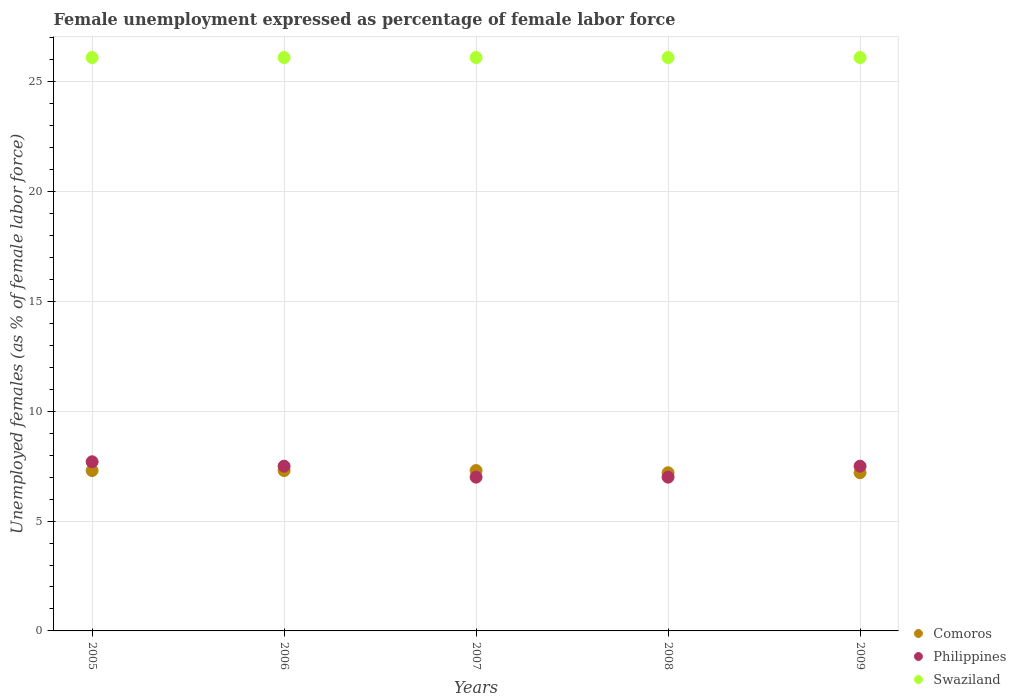How many different coloured dotlines are there?
Offer a terse response. 3. What is the unemployment in females in in Philippines in 2009?
Offer a very short reply. 7.5. Across all years, what is the maximum unemployment in females in in Philippines?
Offer a very short reply. 7.7. Across all years, what is the minimum unemployment in females in in Comoros?
Provide a succinct answer. 7.2. What is the total unemployment in females in in Philippines in the graph?
Ensure brevity in your answer.  36.7. What is the difference between the unemployment in females in in Swaziland in 2005 and the unemployment in females in in Philippines in 2008?
Provide a short and direct response. 19.1. What is the average unemployment in females in in Philippines per year?
Offer a terse response. 7.34. In the year 2007, what is the difference between the unemployment in females in in Comoros and unemployment in females in in Philippines?
Provide a succinct answer. 0.3. What is the ratio of the unemployment in females in in Philippines in 2005 to that in 2008?
Keep it short and to the point. 1.1. Is the unemployment in females in in Comoros in 2005 less than that in 2007?
Provide a short and direct response. No. Is the difference between the unemployment in females in in Comoros in 2008 and 2009 greater than the difference between the unemployment in females in in Philippines in 2008 and 2009?
Make the answer very short. Yes. What is the difference between the highest and the second highest unemployment in females in in Comoros?
Keep it short and to the point. 0. What is the difference between the highest and the lowest unemployment in females in in Swaziland?
Keep it short and to the point. 0. What is the difference between two consecutive major ticks on the Y-axis?
Your answer should be compact. 5. Does the graph contain any zero values?
Make the answer very short. No. Does the graph contain grids?
Ensure brevity in your answer.  Yes. Where does the legend appear in the graph?
Give a very brief answer. Bottom right. What is the title of the graph?
Keep it short and to the point. Female unemployment expressed as percentage of female labor force. What is the label or title of the X-axis?
Give a very brief answer. Years. What is the label or title of the Y-axis?
Your answer should be compact. Unemployed females (as % of female labor force). What is the Unemployed females (as % of female labor force) in Comoros in 2005?
Offer a very short reply. 7.3. What is the Unemployed females (as % of female labor force) of Philippines in 2005?
Ensure brevity in your answer.  7.7. What is the Unemployed females (as % of female labor force) in Swaziland in 2005?
Provide a short and direct response. 26.1. What is the Unemployed females (as % of female labor force) of Comoros in 2006?
Ensure brevity in your answer.  7.3. What is the Unemployed females (as % of female labor force) of Swaziland in 2006?
Provide a succinct answer. 26.1. What is the Unemployed females (as % of female labor force) in Comoros in 2007?
Your answer should be very brief. 7.3. What is the Unemployed females (as % of female labor force) in Swaziland in 2007?
Provide a short and direct response. 26.1. What is the Unemployed females (as % of female labor force) in Comoros in 2008?
Make the answer very short. 7.2. What is the Unemployed females (as % of female labor force) of Swaziland in 2008?
Make the answer very short. 26.1. What is the Unemployed females (as % of female labor force) in Comoros in 2009?
Keep it short and to the point. 7.2. What is the Unemployed females (as % of female labor force) of Philippines in 2009?
Your response must be concise. 7.5. What is the Unemployed females (as % of female labor force) in Swaziland in 2009?
Give a very brief answer. 26.1. Across all years, what is the maximum Unemployed females (as % of female labor force) in Comoros?
Provide a short and direct response. 7.3. Across all years, what is the maximum Unemployed females (as % of female labor force) in Philippines?
Offer a terse response. 7.7. Across all years, what is the maximum Unemployed females (as % of female labor force) of Swaziland?
Your response must be concise. 26.1. Across all years, what is the minimum Unemployed females (as % of female labor force) of Comoros?
Make the answer very short. 7.2. Across all years, what is the minimum Unemployed females (as % of female labor force) of Swaziland?
Your answer should be very brief. 26.1. What is the total Unemployed females (as % of female labor force) in Comoros in the graph?
Give a very brief answer. 36.3. What is the total Unemployed females (as % of female labor force) of Philippines in the graph?
Offer a very short reply. 36.7. What is the total Unemployed females (as % of female labor force) in Swaziland in the graph?
Your answer should be compact. 130.5. What is the difference between the Unemployed females (as % of female labor force) of Comoros in 2005 and that in 2006?
Give a very brief answer. 0. What is the difference between the Unemployed females (as % of female labor force) of Philippines in 2005 and that in 2006?
Provide a short and direct response. 0.2. What is the difference between the Unemployed females (as % of female labor force) in Swaziland in 2005 and that in 2006?
Keep it short and to the point. 0. What is the difference between the Unemployed females (as % of female labor force) of Philippines in 2005 and that in 2008?
Your response must be concise. 0.7. What is the difference between the Unemployed females (as % of female labor force) of Comoros in 2005 and that in 2009?
Keep it short and to the point. 0.1. What is the difference between the Unemployed females (as % of female labor force) in Philippines in 2005 and that in 2009?
Your answer should be very brief. 0.2. What is the difference between the Unemployed females (as % of female labor force) in Swaziland in 2005 and that in 2009?
Provide a succinct answer. 0. What is the difference between the Unemployed females (as % of female labor force) in Philippines in 2006 and that in 2008?
Your answer should be very brief. 0.5. What is the difference between the Unemployed females (as % of female labor force) of Swaziland in 2006 and that in 2009?
Offer a very short reply. 0. What is the difference between the Unemployed females (as % of female labor force) in Swaziland in 2007 and that in 2008?
Provide a succinct answer. 0. What is the difference between the Unemployed females (as % of female labor force) of Comoros in 2007 and that in 2009?
Your answer should be compact. 0.1. What is the difference between the Unemployed females (as % of female labor force) in Philippines in 2008 and that in 2009?
Make the answer very short. -0.5. What is the difference between the Unemployed females (as % of female labor force) in Comoros in 2005 and the Unemployed females (as % of female labor force) in Swaziland in 2006?
Offer a very short reply. -18.8. What is the difference between the Unemployed females (as % of female labor force) in Philippines in 2005 and the Unemployed females (as % of female labor force) in Swaziland in 2006?
Offer a terse response. -18.4. What is the difference between the Unemployed females (as % of female labor force) of Comoros in 2005 and the Unemployed females (as % of female labor force) of Philippines in 2007?
Give a very brief answer. 0.3. What is the difference between the Unemployed females (as % of female labor force) of Comoros in 2005 and the Unemployed females (as % of female labor force) of Swaziland in 2007?
Give a very brief answer. -18.8. What is the difference between the Unemployed females (as % of female labor force) of Philippines in 2005 and the Unemployed females (as % of female labor force) of Swaziland in 2007?
Provide a short and direct response. -18.4. What is the difference between the Unemployed females (as % of female labor force) of Comoros in 2005 and the Unemployed females (as % of female labor force) of Swaziland in 2008?
Your answer should be very brief. -18.8. What is the difference between the Unemployed females (as % of female labor force) in Philippines in 2005 and the Unemployed females (as % of female labor force) in Swaziland in 2008?
Provide a succinct answer. -18.4. What is the difference between the Unemployed females (as % of female labor force) of Comoros in 2005 and the Unemployed females (as % of female labor force) of Swaziland in 2009?
Provide a short and direct response. -18.8. What is the difference between the Unemployed females (as % of female labor force) in Philippines in 2005 and the Unemployed females (as % of female labor force) in Swaziland in 2009?
Ensure brevity in your answer.  -18.4. What is the difference between the Unemployed females (as % of female labor force) of Comoros in 2006 and the Unemployed females (as % of female labor force) of Swaziland in 2007?
Ensure brevity in your answer.  -18.8. What is the difference between the Unemployed females (as % of female labor force) of Philippines in 2006 and the Unemployed females (as % of female labor force) of Swaziland in 2007?
Provide a short and direct response. -18.6. What is the difference between the Unemployed females (as % of female labor force) of Comoros in 2006 and the Unemployed females (as % of female labor force) of Philippines in 2008?
Make the answer very short. 0.3. What is the difference between the Unemployed females (as % of female labor force) of Comoros in 2006 and the Unemployed females (as % of female labor force) of Swaziland in 2008?
Provide a short and direct response. -18.8. What is the difference between the Unemployed females (as % of female labor force) in Philippines in 2006 and the Unemployed females (as % of female labor force) in Swaziland in 2008?
Your answer should be very brief. -18.6. What is the difference between the Unemployed females (as % of female labor force) in Comoros in 2006 and the Unemployed females (as % of female labor force) in Swaziland in 2009?
Your answer should be compact. -18.8. What is the difference between the Unemployed females (as % of female labor force) of Philippines in 2006 and the Unemployed females (as % of female labor force) of Swaziland in 2009?
Offer a terse response. -18.6. What is the difference between the Unemployed females (as % of female labor force) of Comoros in 2007 and the Unemployed females (as % of female labor force) of Philippines in 2008?
Provide a succinct answer. 0.3. What is the difference between the Unemployed females (as % of female labor force) of Comoros in 2007 and the Unemployed females (as % of female labor force) of Swaziland in 2008?
Keep it short and to the point. -18.8. What is the difference between the Unemployed females (as % of female labor force) of Philippines in 2007 and the Unemployed females (as % of female labor force) of Swaziland in 2008?
Give a very brief answer. -19.1. What is the difference between the Unemployed females (as % of female labor force) of Comoros in 2007 and the Unemployed females (as % of female labor force) of Swaziland in 2009?
Your response must be concise. -18.8. What is the difference between the Unemployed females (as % of female labor force) in Philippines in 2007 and the Unemployed females (as % of female labor force) in Swaziland in 2009?
Make the answer very short. -19.1. What is the difference between the Unemployed females (as % of female labor force) in Comoros in 2008 and the Unemployed females (as % of female labor force) in Swaziland in 2009?
Offer a terse response. -18.9. What is the difference between the Unemployed females (as % of female labor force) of Philippines in 2008 and the Unemployed females (as % of female labor force) of Swaziland in 2009?
Provide a succinct answer. -19.1. What is the average Unemployed females (as % of female labor force) in Comoros per year?
Your answer should be compact. 7.26. What is the average Unemployed females (as % of female labor force) of Philippines per year?
Offer a terse response. 7.34. What is the average Unemployed females (as % of female labor force) of Swaziland per year?
Your answer should be very brief. 26.1. In the year 2005, what is the difference between the Unemployed females (as % of female labor force) in Comoros and Unemployed females (as % of female labor force) in Swaziland?
Provide a succinct answer. -18.8. In the year 2005, what is the difference between the Unemployed females (as % of female labor force) in Philippines and Unemployed females (as % of female labor force) in Swaziland?
Your answer should be very brief. -18.4. In the year 2006, what is the difference between the Unemployed females (as % of female labor force) of Comoros and Unemployed females (as % of female labor force) of Philippines?
Offer a terse response. -0.2. In the year 2006, what is the difference between the Unemployed females (as % of female labor force) of Comoros and Unemployed females (as % of female labor force) of Swaziland?
Your answer should be compact. -18.8. In the year 2006, what is the difference between the Unemployed females (as % of female labor force) of Philippines and Unemployed females (as % of female labor force) of Swaziland?
Make the answer very short. -18.6. In the year 2007, what is the difference between the Unemployed females (as % of female labor force) in Comoros and Unemployed females (as % of female labor force) in Philippines?
Ensure brevity in your answer.  0.3. In the year 2007, what is the difference between the Unemployed females (as % of female labor force) of Comoros and Unemployed females (as % of female labor force) of Swaziland?
Ensure brevity in your answer.  -18.8. In the year 2007, what is the difference between the Unemployed females (as % of female labor force) of Philippines and Unemployed females (as % of female labor force) of Swaziland?
Offer a terse response. -19.1. In the year 2008, what is the difference between the Unemployed females (as % of female labor force) of Comoros and Unemployed females (as % of female labor force) of Swaziland?
Provide a short and direct response. -18.9. In the year 2008, what is the difference between the Unemployed females (as % of female labor force) in Philippines and Unemployed females (as % of female labor force) in Swaziland?
Keep it short and to the point. -19.1. In the year 2009, what is the difference between the Unemployed females (as % of female labor force) of Comoros and Unemployed females (as % of female labor force) of Swaziland?
Give a very brief answer. -18.9. In the year 2009, what is the difference between the Unemployed females (as % of female labor force) of Philippines and Unemployed females (as % of female labor force) of Swaziland?
Ensure brevity in your answer.  -18.6. What is the ratio of the Unemployed females (as % of female labor force) in Philippines in 2005 to that in 2006?
Give a very brief answer. 1.03. What is the ratio of the Unemployed females (as % of female labor force) in Swaziland in 2005 to that in 2006?
Give a very brief answer. 1. What is the ratio of the Unemployed females (as % of female labor force) in Comoros in 2005 to that in 2007?
Keep it short and to the point. 1. What is the ratio of the Unemployed females (as % of female labor force) of Philippines in 2005 to that in 2007?
Provide a succinct answer. 1.1. What is the ratio of the Unemployed females (as % of female labor force) of Swaziland in 2005 to that in 2007?
Your answer should be very brief. 1. What is the ratio of the Unemployed females (as % of female labor force) in Comoros in 2005 to that in 2008?
Give a very brief answer. 1.01. What is the ratio of the Unemployed females (as % of female labor force) in Swaziland in 2005 to that in 2008?
Give a very brief answer. 1. What is the ratio of the Unemployed females (as % of female labor force) in Comoros in 2005 to that in 2009?
Your response must be concise. 1.01. What is the ratio of the Unemployed females (as % of female labor force) in Philippines in 2005 to that in 2009?
Offer a very short reply. 1.03. What is the ratio of the Unemployed females (as % of female labor force) in Swaziland in 2005 to that in 2009?
Provide a succinct answer. 1. What is the ratio of the Unemployed females (as % of female labor force) of Philippines in 2006 to that in 2007?
Your answer should be very brief. 1.07. What is the ratio of the Unemployed females (as % of female labor force) in Comoros in 2006 to that in 2008?
Ensure brevity in your answer.  1.01. What is the ratio of the Unemployed females (as % of female labor force) in Philippines in 2006 to that in 2008?
Make the answer very short. 1.07. What is the ratio of the Unemployed females (as % of female labor force) in Swaziland in 2006 to that in 2008?
Offer a very short reply. 1. What is the ratio of the Unemployed females (as % of female labor force) in Comoros in 2006 to that in 2009?
Ensure brevity in your answer.  1.01. What is the ratio of the Unemployed females (as % of female labor force) in Philippines in 2006 to that in 2009?
Your answer should be compact. 1. What is the ratio of the Unemployed females (as % of female labor force) in Comoros in 2007 to that in 2008?
Your answer should be very brief. 1.01. What is the ratio of the Unemployed females (as % of female labor force) of Philippines in 2007 to that in 2008?
Ensure brevity in your answer.  1. What is the ratio of the Unemployed females (as % of female labor force) of Comoros in 2007 to that in 2009?
Your response must be concise. 1.01. What is the ratio of the Unemployed females (as % of female labor force) in Swaziland in 2007 to that in 2009?
Your response must be concise. 1. What is the ratio of the Unemployed females (as % of female labor force) in Comoros in 2008 to that in 2009?
Ensure brevity in your answer.  1. What is the ratio of the Unemployed females (as % of female labor force) in Philippines in 2008 to that in 2009?
Make the answer very short. 0.93. What is the ratio of the Unemployed females (as % of female labor force) of Swaziland in 2008 to that in 2009?
Give a very brief answer. 1. What is the difference between the highest and the second highest Unemployed females (as % of female labor force) in Comoros?
Ensure brevity in your answer.  0. What is the difference between the highest and the second highest Unemployed females (as % of female labor force) in Philippines?
Provide a succinct answer. 0.2. What is the difference between the highest and the second highest Unemployed females (as % of female labor force) of Swaziland?
Your answer should be compact. 0. What is the difference between the highest and the lowest Unemployed females (as % of female labor force) of Comoros?
Provide a succinct answer. 0.1. What is the difference between the highest and the lowest Unemployed females (as % of female labor force) in Swaziland?
Give a very brief answer. 0. 